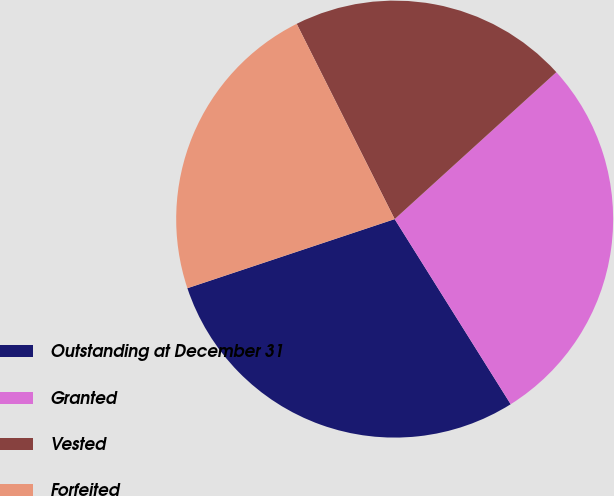Convert chart to OTSL. <chart><loc_0><loc_0><loc_500><loc_500><pie_chart><fcel>Outstanding at December 31<fcel>Granted<fcel>Vested<fcel>Forfeited<nl><fcel>28.79%<fcel>27.83%<fcel>20.66%<fcel>22.72%<nl></chart> 